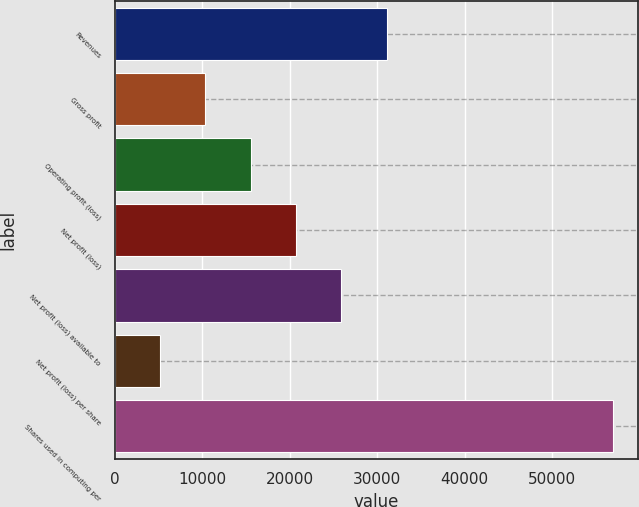Convert chart to OTSL. <chart><loc_0><loc_0><loc_500><loc_500><bar_chart><fcel>Revenues<fcel>Gross profit<fcel>Operating profit (loss)<fcel>Net profit (loss)<fcel>Net profit (loss) available to<fcel>Net profit (loss) per share<fcel>Shares used in computing per<nl><fcel>31077.7<fcel>10359.4<fcel>15539<fcel>20718.6<fcel>25898.2<fcel>5179.87<fcel>56975.6<nl></chart> 